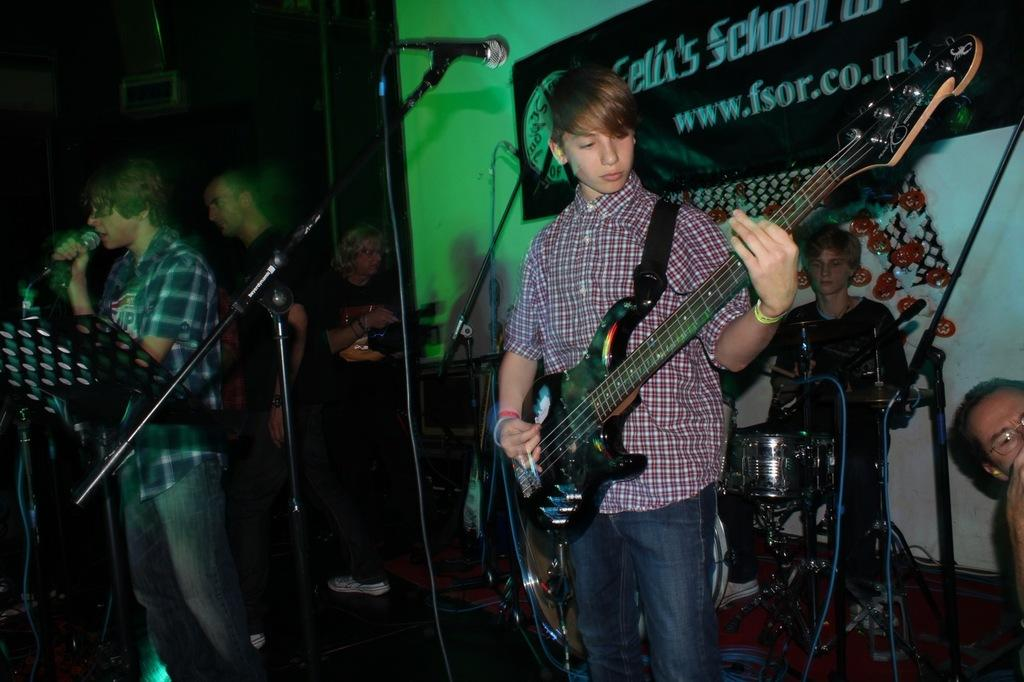What are the people on the stage doing? The people on the stage are performing by playing musical instruments and singing. How are they using their voices in the performance? They are singing as part of their performance. What can be seen in the image that might be used for amplifying their voices? There is a microphone in the image. What is on the wall that might indicate the event or group? There is a banner on the wall. Can you see a circle of men dancing around a hill in the image? No, there is no circle of men dancing around a hill in the image. The image features people on a stage performing with musical instruments and singing, along with a microphone and a banner on the wall. 